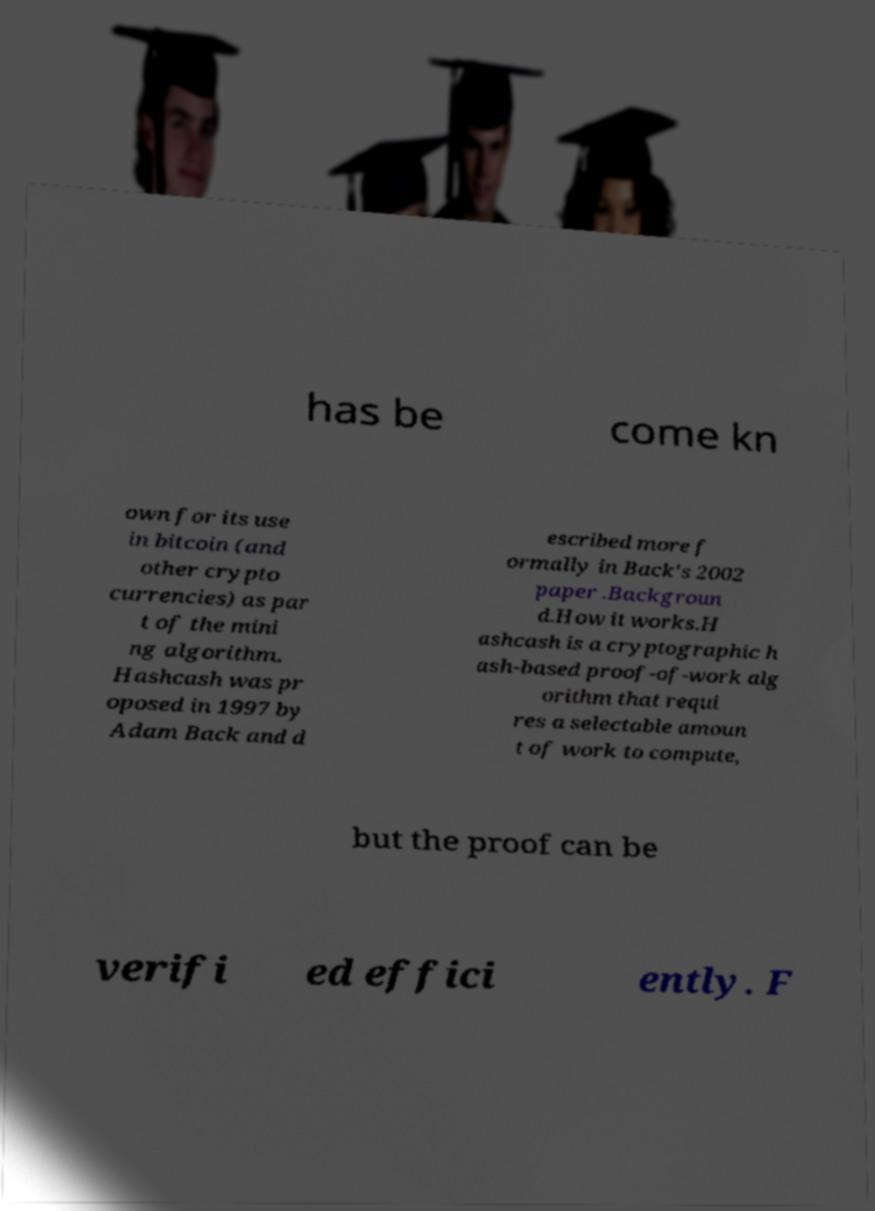Can you read and provide the text displayed in the image?This photo seems to have some interesting text. Can you extract and type it out for me? has be come kn own for its use in bitcoin (and other crypto currencies) as par t of the mini ng algorithm. Hashcash was pr oposed in 1997 by Adam Back and d escribed more f ormally in Back's 2002 paper .Backgroun d.How it works.H ashcash is a cryptographic h ash-based proof-of-work alg orithm that requi res a selectable amoun t of work to compute, but the proof can be verifi ed effici ently. F 